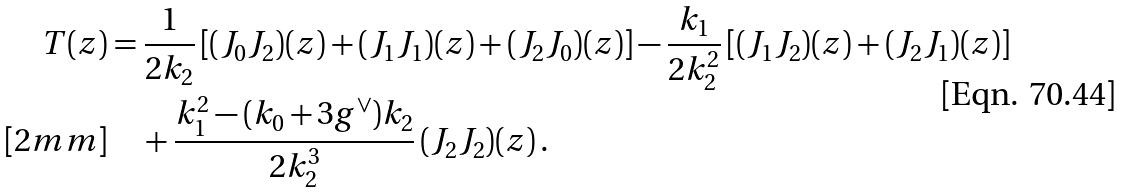Convert formula to latex. <formula><loc_0><loc_0><loc_500><loc_500>T ( z ) & = \frac { 1 } { 2 k _ { 2 } } \left [ ( J _ { 0 } J _ { 2 } ) ( z ) + ( J _ { 1 } J _ { 1 } ) ( z ) + ( J _ { 2 } J _ { 0 } ) ( z ) \right ] - \frac { k _ { 1 } } { 2 k _ { 2 } ^ { 2 } } \left [ ( J _ { 1 } J _ { 2 } ) ( z ) + ( J _ { 2 } J _ { 1 } ) ( z ) \right ] \\ [ 2 m m ] & \quad + \frac { k _ { 1 } ^ { 2 } - ( k _ { 0 } + 3 g ^ { \vee } ) k _ { 2 } } { 2 k _ { 2 } ^ { 3 } } \, ( J _ { 2 } J _ { 2 } ) ( z ) \, .</formula> 